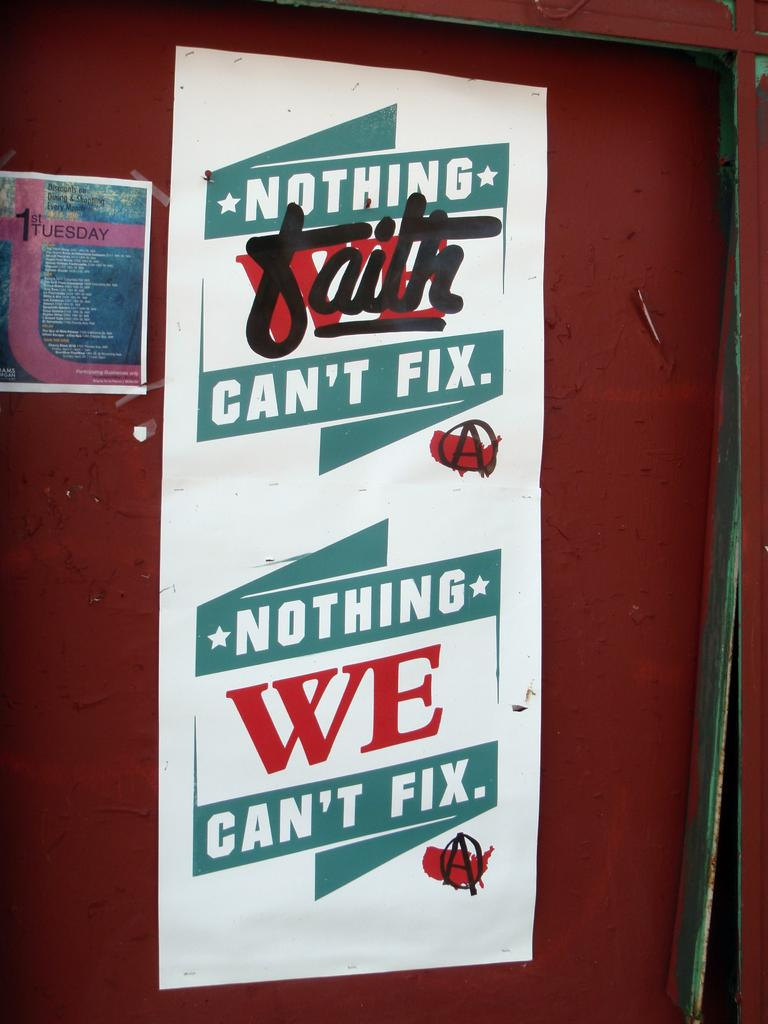<image>
Provide a brief description of the given image. A sign that says Nothing we can't fix and we is crossed off and replaced with faith 